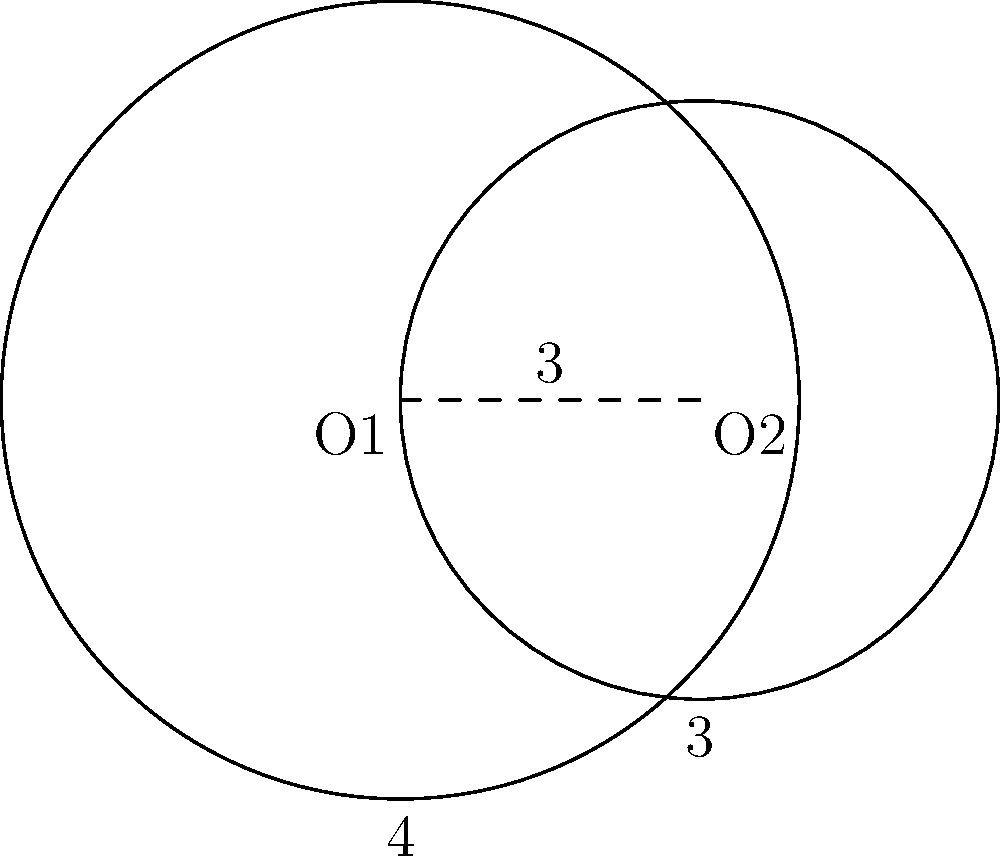Two circles with radii 4 cm and 3 cm have their centers 3 cm apart, as shown in the figure. Calculate the area of the region between the two intersecting circles. Let's approach this step-by-step:

1) First, we need to find the angle θ at the center of each circle formed by the line joining the centers and the line to an intersection point.

   For the larger circle: $\cos \theta_1 = \frac{3^2 + 4^2 - 3^2}{2 \cdot 3 \cdot 4} = \frac{7}{8}$
   $\theta_1 = \arccos(\frac{7}{8}) \approx 0.5054$ radians

   For the smaller circle: $\cos \theta_2 = \frac{3^2 + 3^2 - 4^2}{2 \cdot 3 \cdot 3} = -\frac{1}{6}$
   $\theta_2 = \arccos(-\frac{1}{6}) \approx 1.7722$ radians

2) The area of a sector is given by $\frac{1}{2}r^2\theta$, where $r$ is the radius and $\theta$ is the angle in radians.

   Area of sector in larger circle: $A_1 = \frac{1}{2} \cdot 4^2 \cdot 2\theta_1 = 8\theta_1 \approx 4.0432$ cm²
   Area of sector in smaller circle: $A_2 = \frac{1}{2} \cdot 3^2 \cdot 2\theta_2 = 9\theta_2 \approx 15.9498$ cm²

3) The area of the triangle formed by the centers and an intersection point:
   $A_t = \frac{1}{2} \cdot 3 \cdot 4 \sin(\theta_1) = 6 \sin(\theta_1) \approx 2.8978$ cm²

4) The area of the region between the circles is the sum of the two sectors minus twice the area of the triangle:

   $A = A_1 + A_2 - 2A_t$
   $A = 8\theta_1 + 9\theta_2 - 12\sin(\theta_1)$
   $A \approx 4.0432 + 15.9498 - 2(2.8978) = 14.1974$ cm²
Answer: $14.20$ cm² (rounded to two decimal places) 